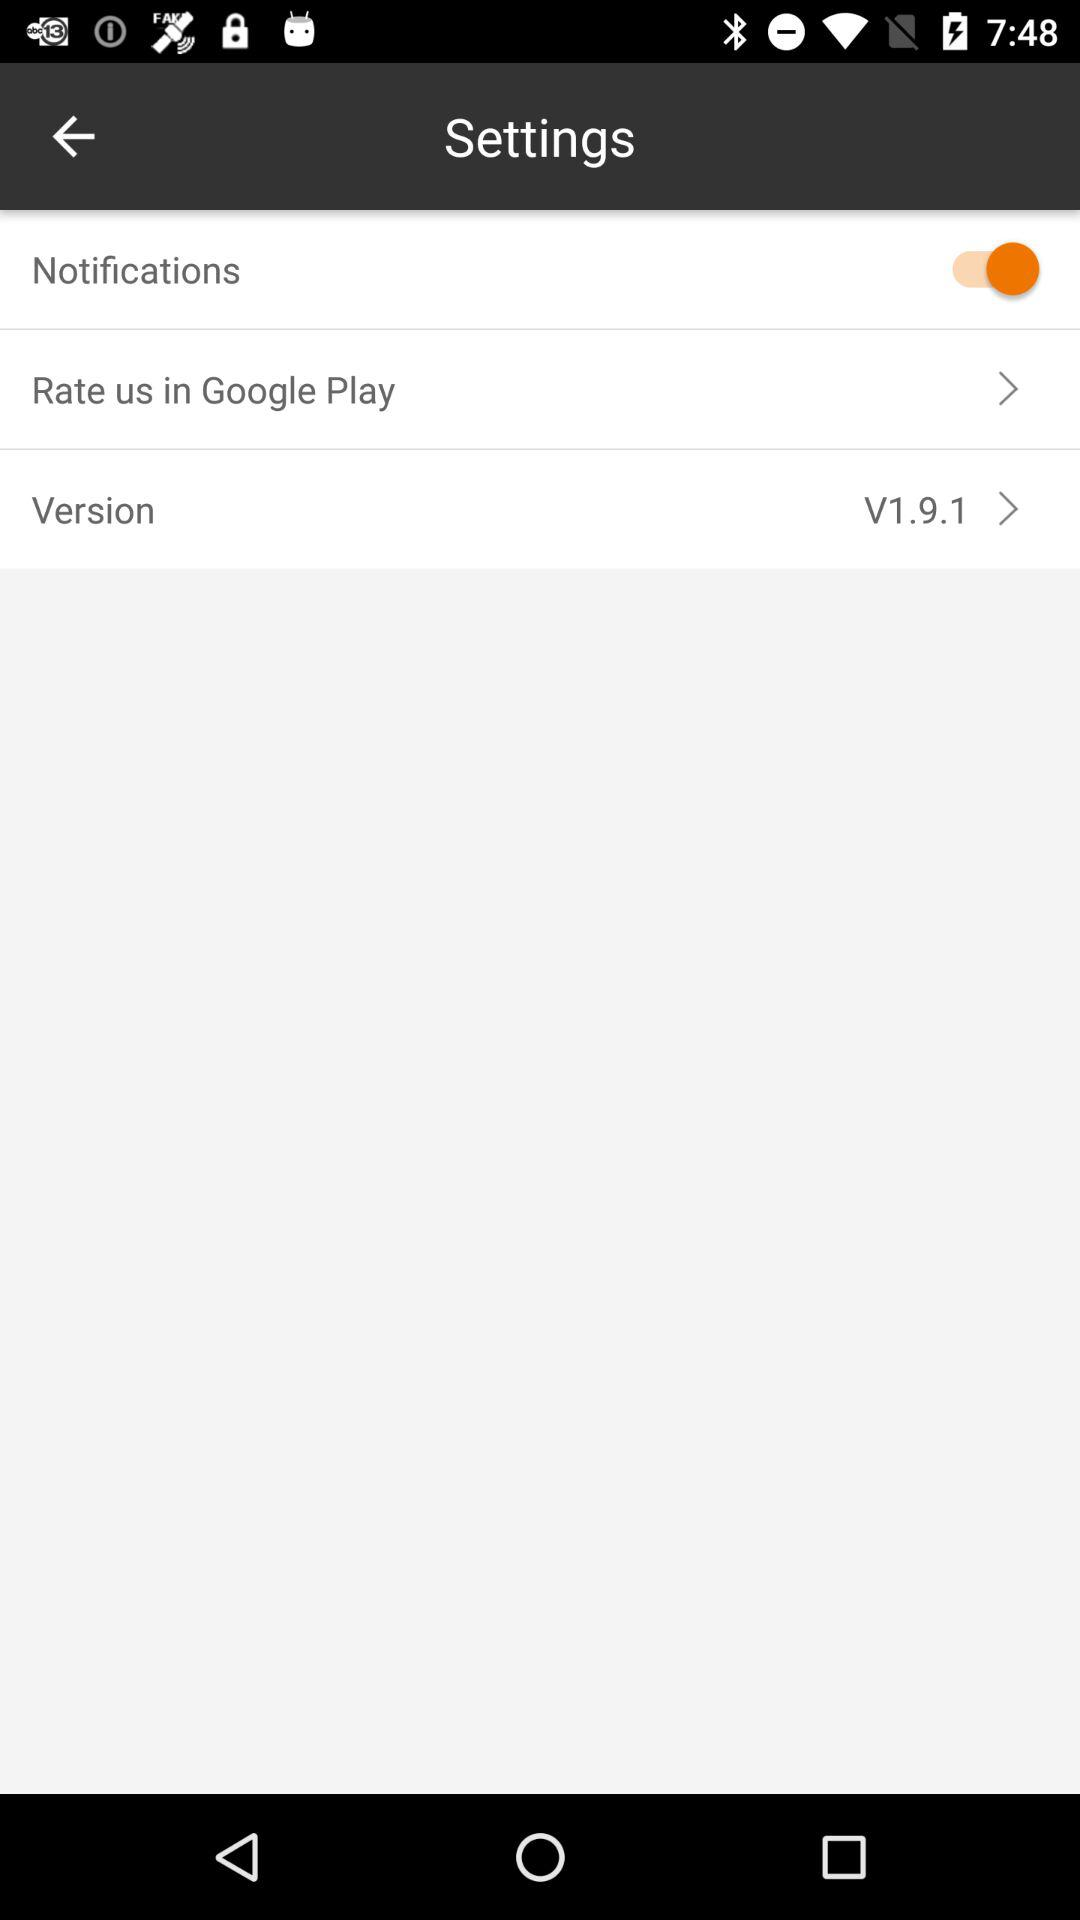Which version is used? The used version is V1.9.1. 